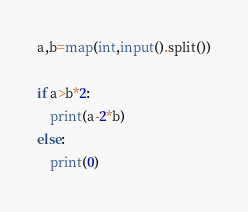Convert code to text. <code><loc_0><loc_0><loc_500><loc_500><_Python_>a,b=map(int,input().split())

if a>b*2:
    print(a-2*b)
else:
    print(0)</code> 